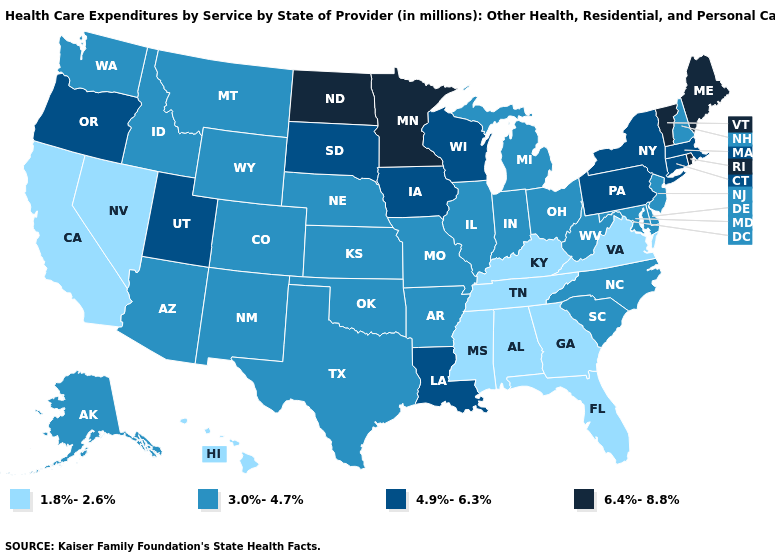Among the states that border New Hampshire , does Massachusetts have the lowest value?
Concise answer only. Yes. What is the value of Tennessee?
Write a very short answer. 1.8%-2.6%. Among the states that border New York , does Massachusetts have the lowest value?
Give a very brief answer. No. What is the lowest value in the West?
Keep it brief. 1.8%-2.6%. Is the legend a continuous bar?
Be succinct. No. Does Rhode Island have the highest value in the USA?
Be succinct. Yes. Does New Hampshire have the highest value in the Northeast?
Write a very short answer. No. What is the highest value in the USA?
Give a very brief answer. 6.4%-8.8%. What is the value of Maryland?
Quick response, please. 3.0%-4.7%. Does Florida have a higher value than Hawaii?
Quick response, please. No. Does Delaware have a lower value than Louisiana?
Give a very brief answer. Yes. Among the states that border Maryland , which have the highest value?
Short answer required. Pennsylvania. Name the states that have a value in the range 4.9%-6.3%?
Give a very brief answer. Connecticut, Iowa, Louisiana, Massachusetts, New York, Oregon, Pennsylvania, South Dakota, Utah, Wisconsin. What is the lowest value in the Northeast?
Answer briefly. 3.0%-4.7%. 